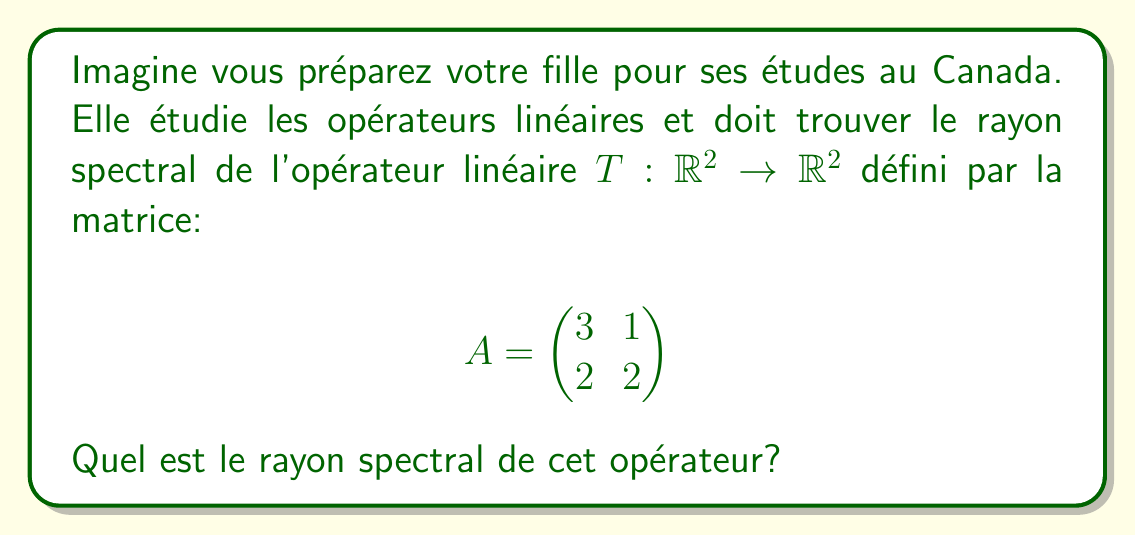Teach me how to tackle this problem. Pour trouver le rayon spectral, suivons ces étapes:

1) D'abord, trouvons les valeurs propres de la matrice $A$. L'équation caractéristique est:

   $$\det(A - \lambda I) = \begin{vmatrix} 3-\lambda & 1 \\ 2 & 2-\lambda \end{vmatrix} = 0$$

2) Développons le déterminant:

   $$(3-\lambda)(2-\lambda) - 2 = 0$$
   $$6 - 5\lambda + \lambda^2 - 2 = 0$$
   $$\lambda^2 - 5\lambda + 4 = 0$$

3) Résolvons cette équation quadratique:

   $$\lambda = \frac{5 \pm \sqrt{25 - 16}}{2} = \frac{5 \pm 3}{2}$$

4) Les valeurs propres sont donc:

   $$\lambda_1 = 4 \text{ et } \lambda_2 = 1$$

5) Le rayon spectral $\rho(A)$ est défini comme le maximum des valeurs absolues des valeurs propres:

   $$\rho(A) = \max(|\lambda_1|, |\lambda_2|) = \max(4, 1) = 4$$

Donc, le rayon spectral de l'opérateur $T$ est 4.
Answer: $4$ 